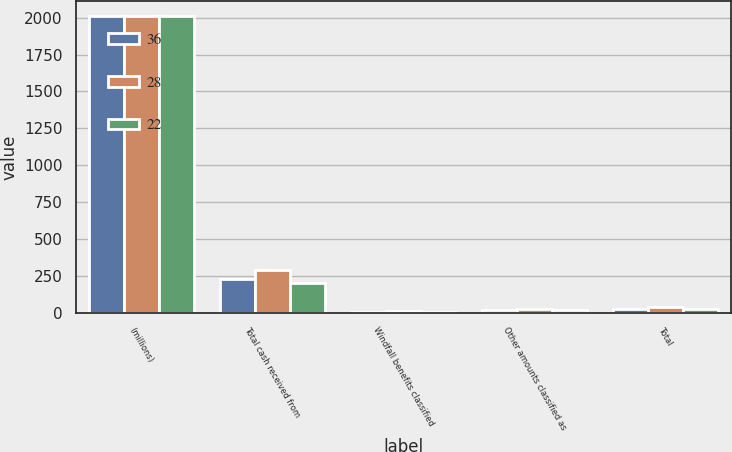Convert chart to OTSL. <chart><loc_0><loc_0><loc_500><loc_500><stacked_bar_chart><ecel><fcel>(millions)<fcel>Total cash received from<fcel>Windfall benefits classified<fcel>Other amounts classified as<fcel>Total<nl><fcel>36<fcel>2012<fcel>229<fcel>6<fcel>16<fcel>22<nl><fcel>28<fcel>2011<fcel>291<fcel>11<fcel>25<fcel>36<nl><fcel>22<fcel>2010<fcel>204<fcel>8<fcel>20<fcel>28<nl></chart> 